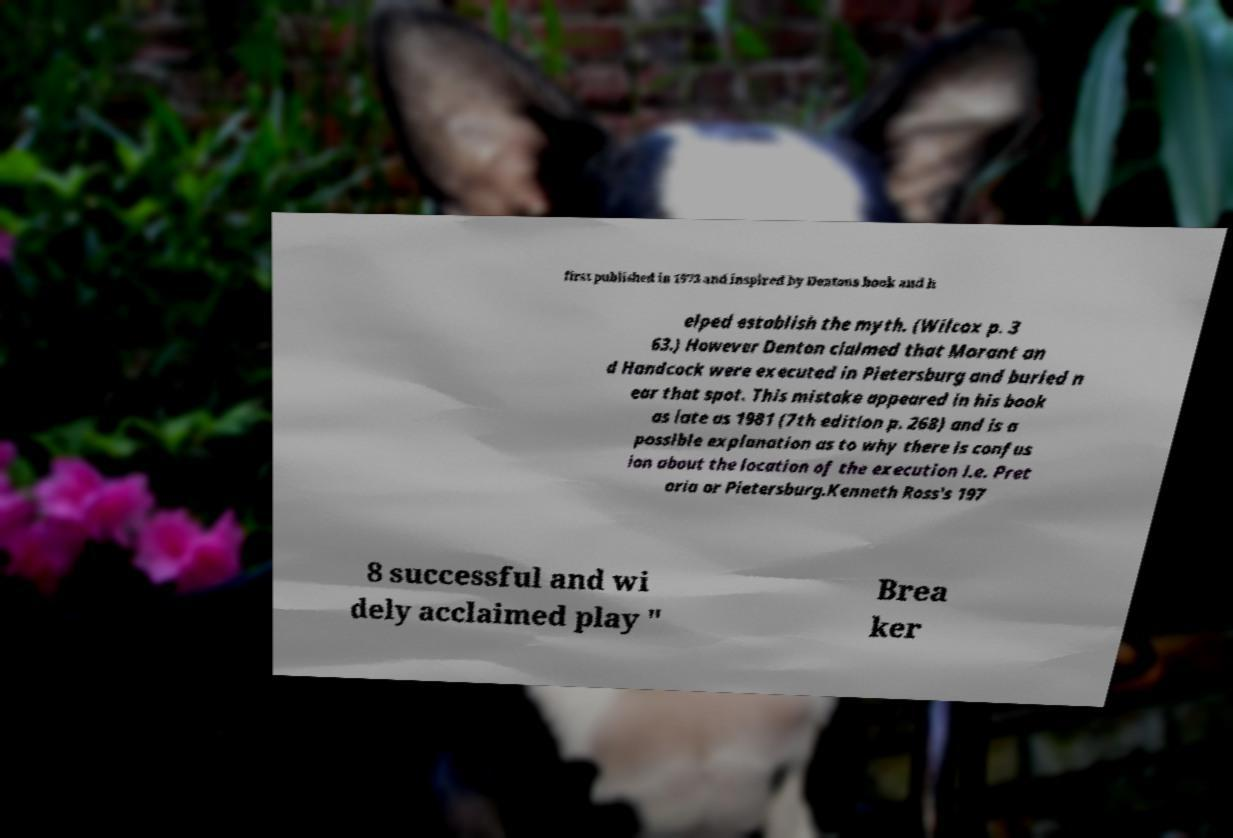For documentation purposes, I need the text within this image transcribed. Could you provide that? first published in 1973 and inspired by Dentons book and h elped establish the myth. (Wilcox p. 3 63.) However Denton claimed that Morant an d Handcock were executed in Pietersburg and buried n ear that spot. This mistake appeared in his book as late as 1981 (7th edition p. 268) and is a possible explanation as to why there is confus ion about the location of the execution i.e. Pret oria or Pietersburg.Kenneth Ross's 197 8 successful and wi dely acclaimed play " Brea ker 